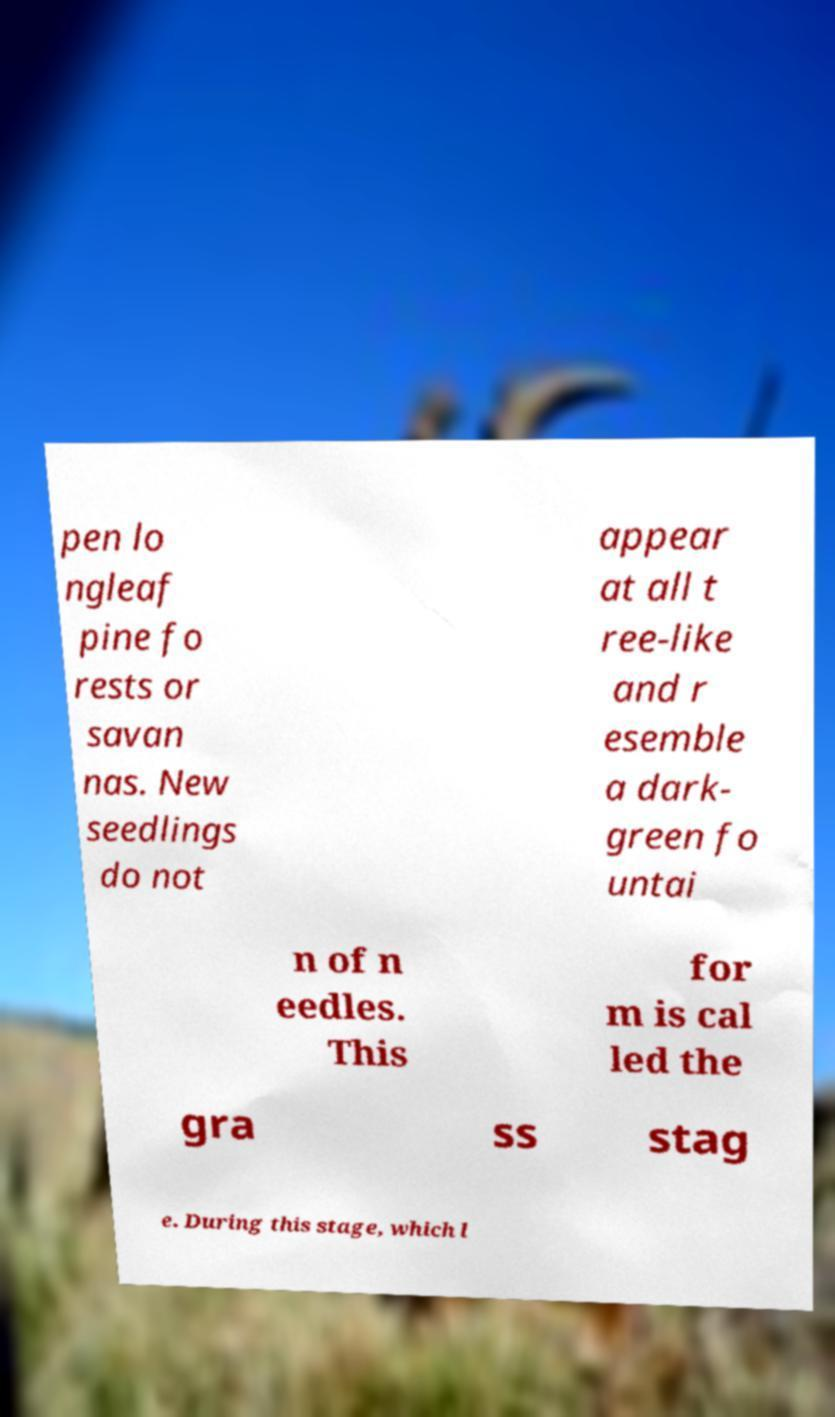Please identify and transcribe the text found in this image. pen lo ngleaf pine fo rests or savan nas. New seedlings do not appear at all t ree-like and r esemble a dark- green fo untai n of n eedles. This for m is cal led the gra ss stag e. During this stage, which l 